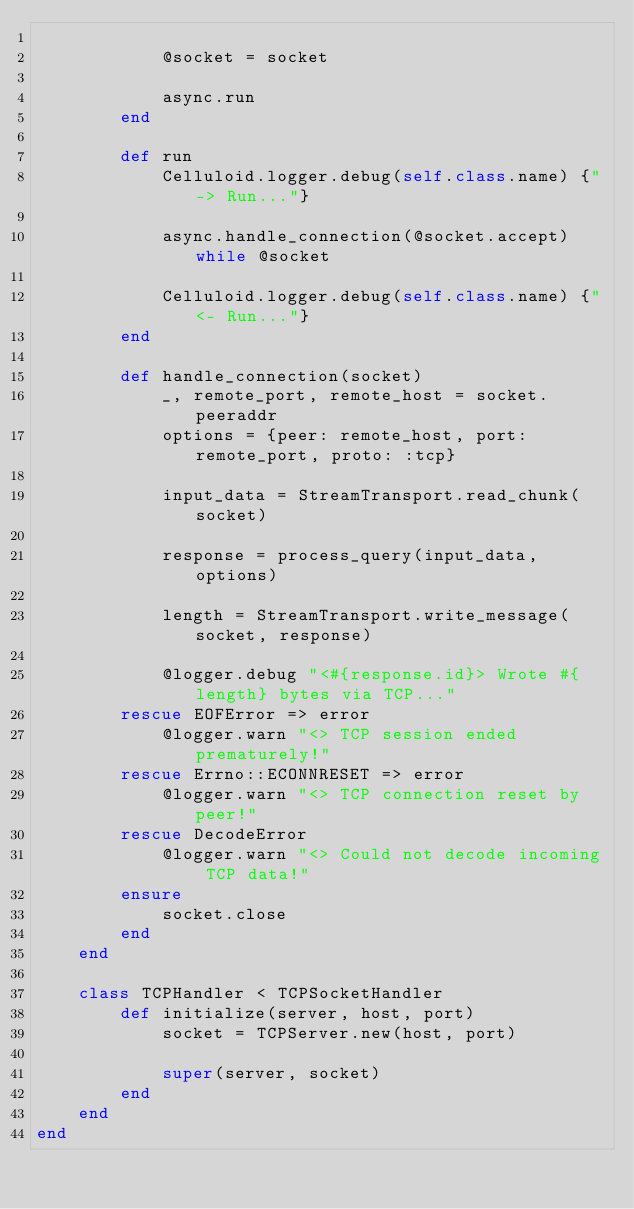Convert code to text. <code><loc_0><loc_0><loc_500><loc_500><_Ruby_>			
			@socket = socket
			
			async.run
		end
		
		def run
			Celluloid.logger.debug(self.class.name) {"-> Run..."}

			async.handle_connection(@socket.accept) while @socket

			Celluloid.logger.debug(self.class.name) {"<- Run..."}
		end
		
		def handle_connection(socket)
			_, remote_port, remote_host = socket.peeraddr
			options = {peer: remote_host, port: remote_port, proto: :tcp}
			
			input_data = StreamTransport.read_chunk(socket)
			
			response = process_query(input_data, options)
			
			length = StreamTransport.write_message(socket, response)
			
			@logger.debug "<#{response.id}> Wrote #{length} bytes via TCP..."
		rescue EOFError => error
			@logger.warn "<> TCP session ended prematurely!"
		rescue Errno::ECONNRESET => error
			@logger.warn "<> TCP connection reset by peer!"
		rescue DecodeError
			@logger.warn "<> Could not decode incoming TCP data!"
		ensure
			socket.close
		end
	end
	
	class TCPHandler < TCPSocketHandler
		def initialize(server, host, port)
			socket = TCPServer.new(host, port)
			
			super(server, socket)
		end
	end
end
</code> 